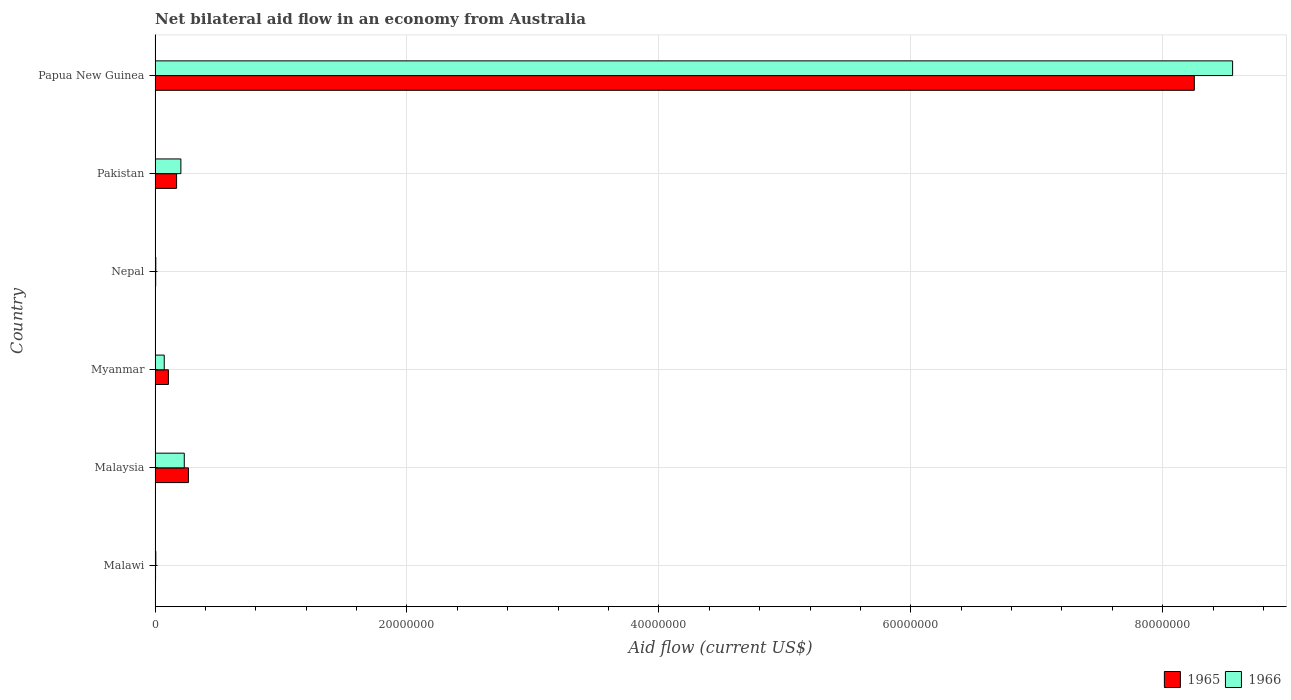How many different coloured bars are there?
Ensure brevity in your answer.  2. How many groups of bars are there?
Ensure brevity in your answer.  6. Are the number of bars on each tick of the Y-axis equal?
Provide a short and direct response. Yes. What is the label of the 3rd group of bars from the top?
Provide a succinct answer. Nepal. Across all countries, what is the maximum net bilateral aid flow in 1966?
Your response must be concise. 8.56e+07. Across all countries, what is the minimum net bilateral aid flow in 1966?
Offer a terse response. 6.00e+04. In which country was the net bilateral aid flow in 1965 maximum?
Keep it short and to the point. Papua New Guinea. In which country was the net bilateral aid flow in 1966 minimum?
Your answer should be very brief. Malawi. What is the total net bilateral aid flow in 1965 in the graph?
Provide a short and direct response. 8.80e+07. What is the difference between the net bilateral aid flow in 1966 in Nepal and that in Papua New Guinea?
Your answer should be compact. -8.55e+07. What is the difference between the net bilateral aid flow in 1966 in Nepal and the net bilateral aid flow in 1965 in Malaysia?
Give a very brief answer. -2.59e+06. What is the average net bilateral aid flow in 1966 per country?
Give a very brief answer. 1.51e+07. What is the difference between the net bilateral aid flow in 1966 and net bilateral aid flow in 1965 in Pakistan?
Your answer should be very brief. 3.40e+05. What is the ratio of the net bilateral aid flow in 1966 in Myanmar to that in Nepal?
Offer a very short reply. 12.17. Is the net bilateral aid flow in 1965 in Malawi less than that in Myanmar?
Offer a terse response. Yes. Is the difference between the net bilateral aid flow in 1966 in Pakistan and Papua New Guinea greater than the difference between the net bilateral aid flow in 1965 in Pakistan and Papua New Guinea?
Offer a terse response. No. What is the difference between the highest and the second highest net bilateral aid flow in 1965?
Provide a short and direct response. 7.99e+07. What is the difference between the highest and the lowest net bilateral aid flow in 1966?
Your response must be concise. 8.55e+07. In how many countries, is the net bilateral aid flow in 1966 greater than the average net bilateral aid flow in 1966 taken over all countries?
Your answer should be compact. 1. What does the 1st bar from the top in Malawi represents?
Provide a succinct answer. 1966. What does the 2nd bar from the bottom in Papua New Guinea represents?
Keep it short and to the point. 1966. How many countries are there in the graph?
Make the answer very short. 6. What is the difference between two consecutive major ticks on the X-axis?
Your answer should be compact. 2.00e+07. Are the values on the major ticks of X-axis written in scientific E-notation?
Ensure brevity in your answer.  No. How many legend labels are there?
Provide a succinct answer. 2. What is the title of the graph?
Your answer should be very brief. Net bilateral aid flow in an economy from Australia. What is the label or title of the Y-axis?
Offer a terse response. Country. What is the Aid flow (current US$) in 1965 in Malawi?
Keep it short and to the point. 4.00e+04. What is the Aid flow (current US$) in 1965 in Malaysia?
Make the answer very short. 2.65e+06. What is the Aid flow (current US$) in 1966 in Malaysia?
Give a very brief answer. 2.32e+06. What is the Aid flow (current US$) in 1965 in Myanmar?
Your answer should be compact. 1.06e+06. What is the Aid flow (current US$) of 1966 in Myanmar?
Make the answer very short. 7.30e+05. What is the Aid flow (current US$) of 1966 in Nepal?
Your answer should be compact. 6.00e+04. What is the Aid flow (current US$) of 1965 in Pakistan?
Make the answer very short. 1.71e+06. What is the Aid flow (current US$) of 1966 in Pakistan?
Your response must be concise. 2.05e+06. What is the Aid flow (current US$) of 1965 in Papua New Guinea?
Give a very brief answer. 8.25e+07. What is the Aid flow (current US$) of 1966 in Papua New Guinea?
Your response must be concise. 8.56e+07. Across all countries, what is the maximum Aid flow (current US$) of 1965?
Provide a succinct answer. 8.25e+07. Across all countries, what is the maximum Aid flow (current US$) in 1966?
Offer a very short reply. 8.56e+07. What is the total Aid flow (current US$) of 1965 in the graph?
Your answer should be very brief. 8.80e+07. What is the total Aid flow (current US$) in 1966 in the graph?
Make the answer very short. 9.08e+07. What is the difference between the Aid flow (current US$) in 1965 in Malawi and that in Malaysia?
Your response must be concise. -2.61e+06. What is the difference between the Aid flow (current US$) of 1966 in Malawi and that in Malaysia?
Provide a succinct answer. -2.26e+06. What is the difference between the Aid flow (current US$) in 1965 in Malawi and that in Myanmar?
Provide a succinct answer. -1.02e+06. What is the difference between the Aid flow (current US$) in 1966 in Malawi and that in Myanmar?
Give a very brief answer. -6.70e+05. What is the difference between the Aid flow (current US$) of 1965 in Malawi and that in Pakistan?
Make the answer very short. -1.67e+06. What is the difference between the Aid flow (current US$) of 1966 in Malawi and that in Pakistan?
Offer a terse response. -1.99e+06. What is the difference between the Aid flow (current US$) of 1965 in Malawi and that in Papua New Guinea?
Provide a succinct answer. -8.25e+07. What is the difference between the Aid flow (current US$) in 1966 in Malawi and that in Papua New Guinea?
Offer a terse response. -8.55e+07. What is the difference between the Aid flow (current US$) of 1965 in Malaysia and that in Myanmar?
Your response must be concise. 1.59e+06. What is the difference between the Aid flow (current US$) in 1966 in Malaysia and that in Myanmar?
Offer a terse response. 1.59e+06. What is the difference between the Aid flow (current US$) of 1965 in Malaysia and that in Nepal?
Provide a succinct answer. 2.60e+06. What is the difference between the Aid flow (current US$) of 1966 in Malaysia and that in Nepal?
Keep it short and to the point. 2.26e+06. What is the difference between the Aid flow (current US$) in 1965 in Malaysia and that in Pakistan?
Your response must be concise. 9.40e+05. What is the difference between the Aid flow (current US$) in 1965 in Malaysia and that in Papua New Guinea?
Your answer should be compact. -7.99e+07. What is the difference between the Aid flow (current US$) in 1966 in Malaysia and that in Papua New Guinea?
Give a very brief answer. -8.32e+07. What is the difference between the Aid flow (current US$) of 1965 in Myanmar and that in Nepal?
Provide a succinct answer. 1.01e+06. What is the difference between the Aid flow (current US$) in 1966 in Myanmar and that in Nepal?
Your answer should be compact. 6.70e+05. What is the difference between the Aid flow (current US$) of 1965 in Myanmar and that in Pakistan?
Keep it short and to the point. -6.50e+05. What is the difference between the Aid flow (current US$) in 1966 in Myanmar and that in Pakistan?
Your response must be concise. -1.32e+06. What is the difference between the Aid flow (current US$) in 1965 in Myanmar and that in Papua New Guinea?
Keep it short and to the point. -8.14e+07. What is the difference between the Aid flow (current US$) of 1966 in Myanmar and that in Papua New Guinea?
Your answer should be compact. -8.48e+07. What is the difference between the Aid flow (current US$) of 1965 in Nepal and that in Pakistan?
Provide a short and direct response. -1.66e+06. What is the difference between the Aid flow (current US$) of 1966 in Nepal and that in Pakistan?
Keep it short and to the point. -1.99e+06. What is the difference between the Aid flow (current US$) of 1965 in Nepal and that in Papua New Guinea?
Keep it short and to the point. -8.25e+07. What is the difference between the Aid flow (current US$) of 1966 in Nepal and that in Papua New Guinea?
Your answer should be very brief. -8.55e+07. What is the difference between the Aid flow (current US$) of 1965 in Pakistan and that in Papua New Guinea?
Provide a short and direct response. -8.08e+07. What is the difference between the Aid flow (current US$) in 1966 in Pakistan and that in Papua New Guinea?
Give a very brief answer. -8.35e+07. What is the difference between the Aid flow (current US$) in 1965 in Malawi and the Aid flow (current US$) in 1966 in Malaysia?
Provide a short and direct response. -2.28e+06. What is the difference between the Aid flow (current US$) in 1965 in Malawi and the Aid flow (current US$) in 1966 in Myanmar?
Give a very brief answer. -6.90e+05. What is the difference between the Aid flow (current US$) of 1965 in Malawi and the Aid flow (current US$) of 1966 in Nepal?
Your answer should be very brief. -2.00e+04. What is the difference between the Aid flow (current US$) of 1965 in Malawi and the Aid flow (current US$) of 1966 in Pakistan?
Provide a short and direct response. -2.01e+06. What is the difference between the Aid flow (current US$) of 1965 in Malawi and the Aid flow (current US$) of 1966 in Papua New Guinea?
Offer a very short reply. -8.55e+07. What is the difference between the Aid flow (current US$) of 1965 in Malaysia and the Aid flow (current US$) of 1966 in Myanmar?
Your answer should be compact. 1.92e+06. What is the difference between the Aid flow (current US$) in 1965 in Malaysia and the Aid flow (current US$) in 1966 in Nepal?
Your answer should be compact. 2.59e+06. What is the difference between the Aid flow (current US$) in 1965 in Malaysia and the Aid flow (current US$) in 1966 in Pakistan?
Your answer should be compact. 6.00e+05. What is the difference between the Aid flow (current US$) of 1965 in Malaysia and the Aid flow (current US$) of 1966 in Papua New Guinea?
Make the answer very short. -8.29e+07. What is the difference between the Aid flow (current US$) of 1965 in Myanmar and the Aid flow (current US$) of 1966 in Nepal?
Your answer should be very brief. 1.00e+06. What is the difference between the Aid flow (current US$) in 1965 in Myanmar and the Aid flow (current US$) in 1966 in Pakistan?
Your response must be concise. -9.90e+05. What is the difference between the Aid flow (current US$) in 1965 in Myanmar and the Aid flow (current US$) in 1966 in Papua New Guinea?
Your answer should be very brief. -8.45e+07. What is the difference between the Aid flow (current US$) in 1965 in Nepal and the Aid flow (current US$) in 1966 in Pakistan?
Give a very brief answer. -2.00e+06. What is the difference between the Aid flow (current US$) of 1965 in Nepal and the Aid flow (current US$) of 1966 in Papua New Guinea?
Provide a succinct answer. -8.55e+07. What is the difference between the Aid flow (current US$) in 1965 in Pakistan and the Aid flow (current US$) in 1966 in Papua New Guinea?
Your response must be concise. -8.38e+07. What is the average Aid flow (current US$) of 1965 per country?
Offer a very short reply. 1.47e+07. What is the average Aid flow (current US$) of 1966 per country?
Ensure brevity in your answer.  1.51e+07. What is the difference between the Aid flow (current US$) of 1965 and Aid flow (current US$) of 1966 in Malawi?
Give a very brief answer. -2.00e+04. What is the difference between the Aid flow (current US$) in 1965 and Aid flow (current US$) in 1966 in Myanmar?
Your answer should be very brief. 3.30e+05. What is the difference between the Aid flow (current US$) of 1965 and Aid flow (current US$) of 1966 in Nepal?
Keep it short and to the point. -10000. What is the difference between the Aid flow (current US$) in 1965 and Aid flow (current US$) in 1966 in Pakistan?
Your answer should be compact. -3.40e+05. What is the difference between the Aid flow (current US$) in 1965 and Aid flow (current US$) in 1966 in Papua New Guinea?
Your answer should be very brief. -3.04e+06. What is the ratio of the Aid flow (current US$) of 1965 in Malawi to that in Malaysia?
Keep it short and to the point. 0.02. What is the ratio of the Aid flow (current US$) in 1966 in Malawi to that in Malaysia?
Ensure brevity in your answer.  0.03. What is the ratio of the Aid flow (current US$) of 1965 in Malawi to that in Myanmar?
Make the answer very short. 0.04. What is the ratio of the Aid flow (current US$) of 1966 in Malawi to that in Myanmar?
Offer a terse response. 0.08. What is the ratio of the Aid flow (current US$) of 1966 in Malawi to that in Nepal?
Ensure brevity in your answer.  1. What is the ratio of the Aid flow (current US$) of 1965 in Malawi to that in Pakistan?
Offer a terse response. 0.02. What is the ratio of the Aid flow (current US$) in 1966 in Malawi to that in Pakistan?
Give a very brief answer. 0.03. What is the ratio of the Aid flow (current US$) of 1965 in Malawi to that in Papua New Guinea?
Your answer should be compact. 0. What is the ratio of the Aid flow (current US$) in 1966 in Malawi to that in Papua New Guinea?
Provide a succinct answer. 0. What is the ratio of the Aid flow (current US$) in 1965 in Malaysia to that in Myanmar?
Offer a terse response. 2.5. What is the ratio of the Aid flow (current US$) in 1966 in Malaysia to that in Myanmar?
Your answer should be very brief. 3.18. What is the ratio of the Aid flow (current US$) in 1965 in Malaysia to that in Nepal?
Your answer should be compact. 53. What is the ratio of the Aid flow (current US$) in 1966 in Malaysia to that in Nepal?
Provide a succinct answer. 38.67. What is the ratio of the Aid flow (current US$) in 1965 in Malaysia to that in Pakistan?
Your answer should be very brief. 1.55. What is the ratio of the Aid flow (current US$) of 1966 in Malaysia to that in Pakistan?
Provide a short and direct response. 1.13. What is the ratio of the Aid flow (current US$) in 1965 in Malaysia to that in Papua New Guinea?
Make the answer very short. 0.03. What is the ratio of the Aid flow (current US$) of 1966 in Malaysia to that in Papua New Guinea?
Ensure brevity in your answer.  0.03. What is the ratio of the Aid flow (current US$) in 1965 in Myanmar to that in Nepal?
Your answer should be very brief. 21.2. What is the ratio of the Aid flow (current US$) in 1966 in Myanmar to that in Nepal?
Your response must be concise. 12.17. What is the ratio of the Aid flow (current US$) of 1965 in Myanmar to that in Pakistan?
Give a very brief answer. 0.62. What is the ratio of the Aid flow (current US$) in 1966 in Myanmar to that in Pakistan?
Provide a succinct answer. 0.36. What is the ratio of the Aid flow (current US$) in 1965 in Myanmar to that in Papua New Guinea?
Your response must be concise. 0.01. What is the ratio of the Aid flow (current US$) of 1966 in Myanmar to that in Papua New Guinea?
Offer a very short reply. 0.01. What is the ratio of the Aid flow (current US$) of 1965 in Nepal to that in Pakistan?
Provide a short and direct response. 0.03. What is the ratio of the Aid flow (current US$) in 1966 in Nepal to that in Pakistan?
Give a very brief answer. 0.03. What is the ratio of the Aid flow (current US$) in 1965 in Nepal to that in Papua New Guinea?
Keep it short and to the point. 0. What is the ratio of the Aid flow (current US$) in 1966 in Nepal to that in Papua New Guinea?
Provide a succinct answer. 0. What is the ratio of the Aid flow (current US$) of 1965 in Pakistan to that in Papua New Guinea?
Ensure brevity in your answer.  0.02. What is the ratio of the Aid flow (current US$) of 1966 in Pakistan to that in Papua New Guinea?
Offer a very short reply. 0.02. What is the difference between the highest and the second highest Aid flow (current US$) of 1965?
Provide a short and direct response. 7.99e+07. What is the difference between the highest and the second highest Aid flow (current US$) in 1966?
Give a very brief answer. 8.32e+07. What is the difference between the highest and the lowest Aid flow (current US$) in 1965?
Offer a very short reply. 8.25e+07. What is the difference between the highest and the lowest Aid flow (current US$) of 1966?
Your answer should be compact. 8.55e+07. 